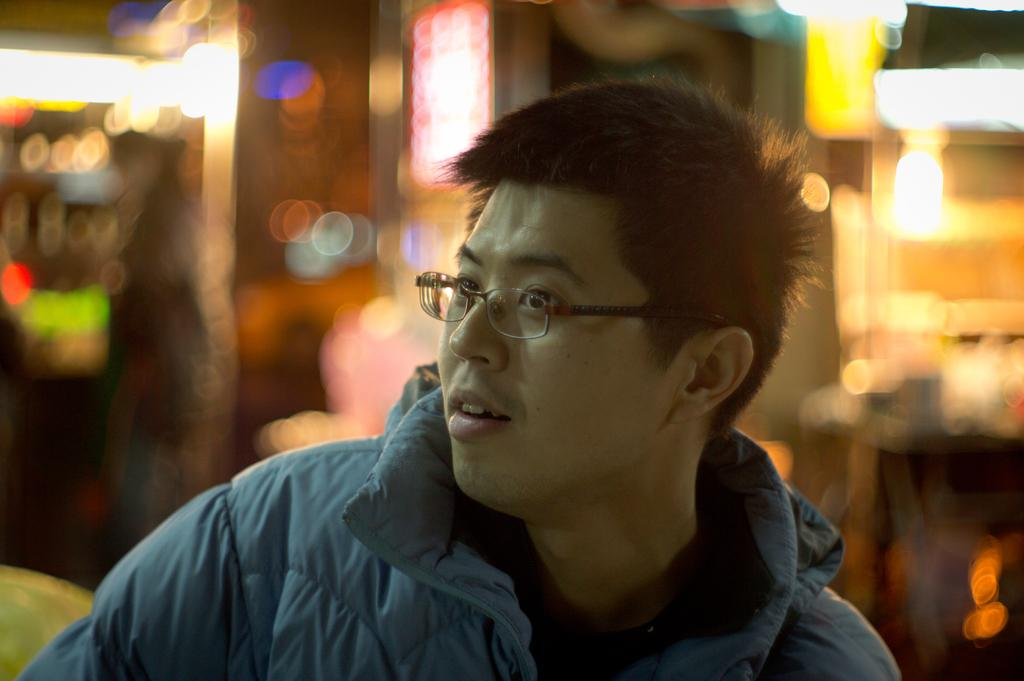What type of clothing is the person in the image wearing? The person in the image is wearing a jacket. What accessory can be seen on the person's face? The person in the image is wearing spectacles. Can you describe the background of the image? The background of the image is blurry. What type of voice does the person's aunt have in the image? There is no mention of an aunt or a voice in the image, so it cannot be determined. 